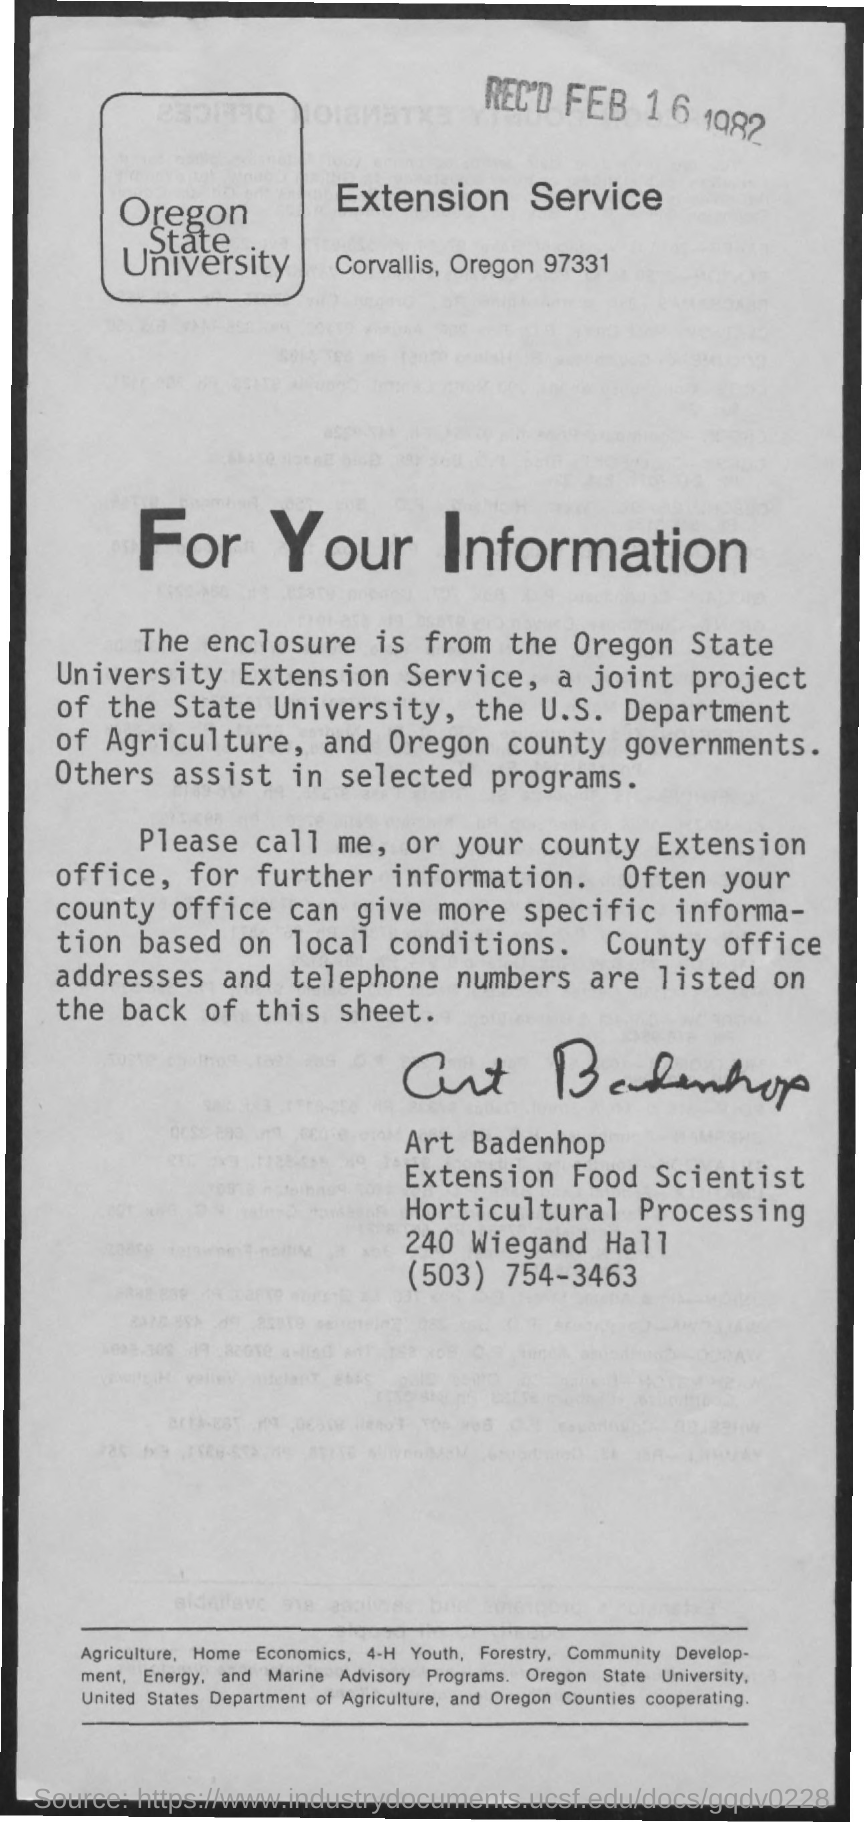Who is the enclosure from?
Keep it short and to the point. Oregon state University extension service. Who is this letter from?
Your answer should be very brief. Art Badenhop. What is the number for Art Badenhop?
Provide a succinct answer. (503) 754-3463. 